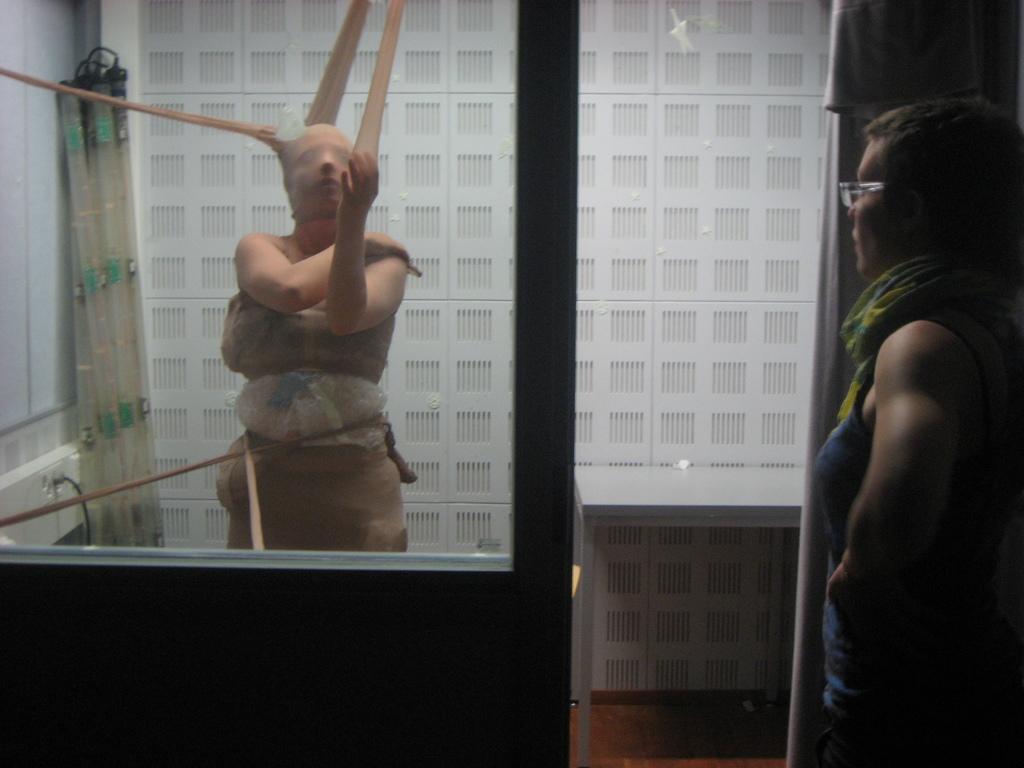Please provide a concise description of this image. This is the picture of a place where we have a person with some clothes and things tied to him and there is an other person in spectacles and behind there is a white wall. 